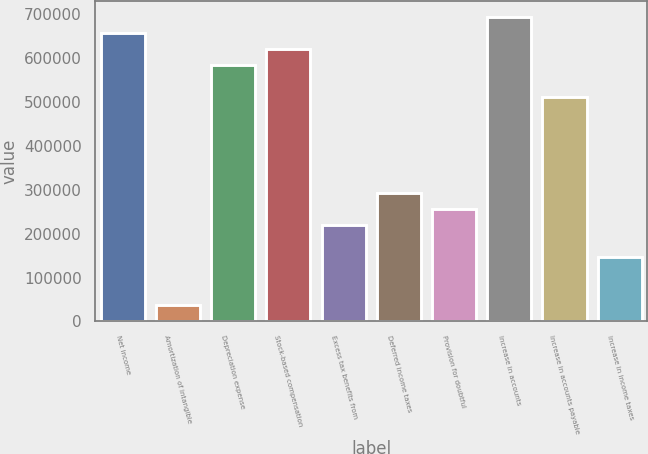Convert chart. <chart><loc_0><loc_0><loc_500><loc_500><bar_chart><fcel>Net income<fcel>Amortization of intangible<fcel>Depreciation expense<fcel>Stock-based compensation<fcel>Excess tax benefits from<fcel>Deferred income taxes<fcel>Provision for doubtful<fcel>Increase in accounts<fcel>Increase in accounts payable<fcel>Increase in income taxes<nl><fcel>658339<fcel>36681.1<fcel>585203<fcel>621771<fcel>219522<fcel>292658<fcel>256090<fcel>694907<fcel>512066<fcel>146385<nl></chart> 